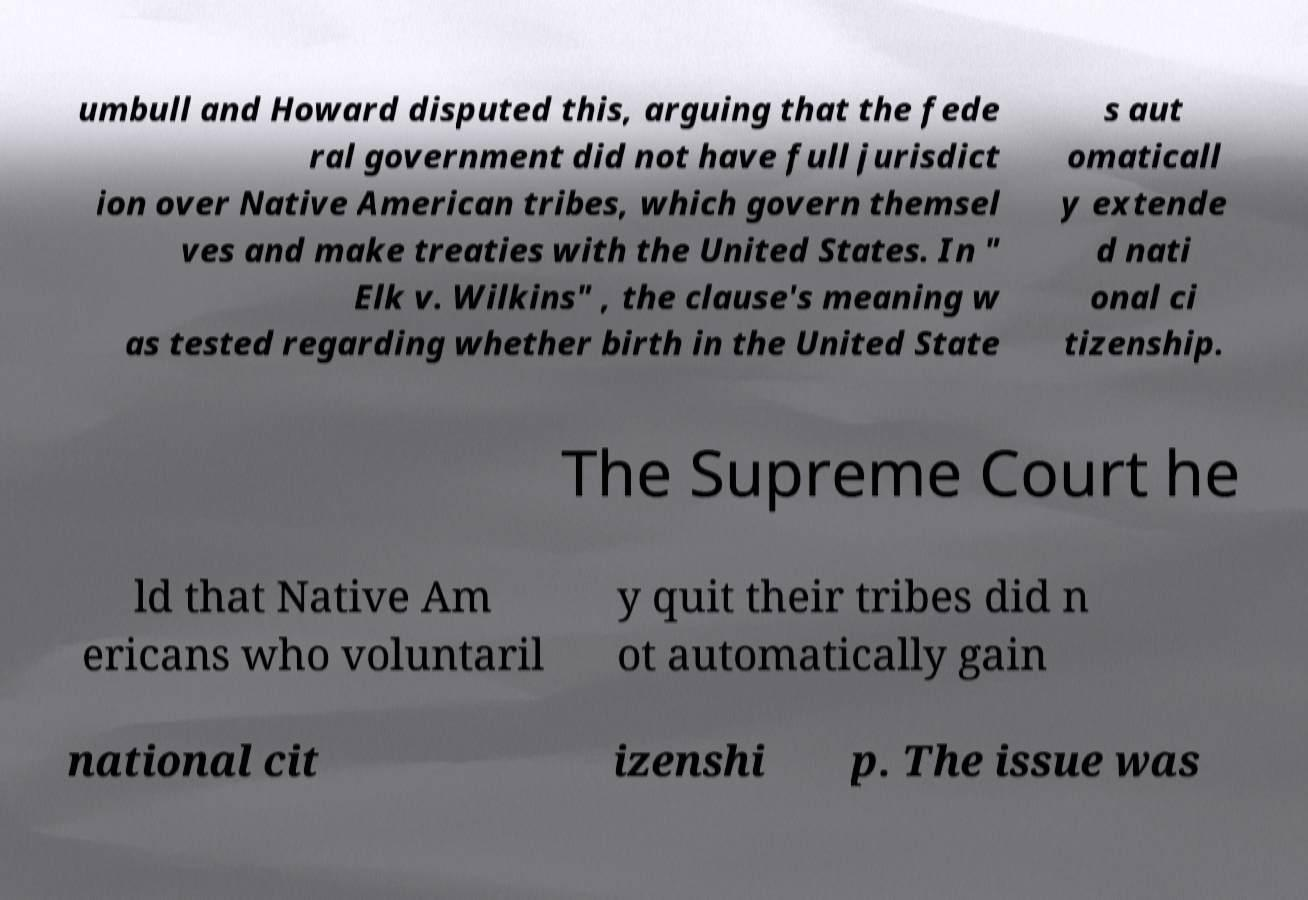Could you assist in decoding the text presented in this image and type it out clearly? umbull and Howard disputed this, arguing that the fede ral government did not have full jurisdict ion over Native American tribes, which govern themsel ves and make treaties with the United States. In " Elk v. Wilkins" , the clause's meaning w as tested regarding whether birth in the United State s aut omaticall y extende d nati onal ci tizenship. The Supreme Court he ld that Native Am ericans who voluntaril y quit their tribes did n ot automatically gain national cit izenshi p. The issue was 